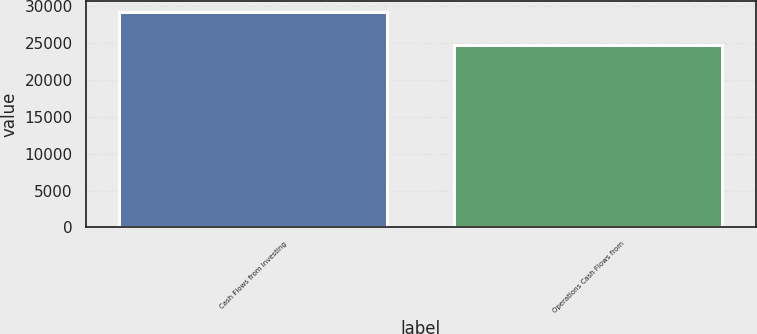<chart> <loc_0><loc_0><loc_500><loc_500><bar_chart><fcel>Cash Flows from Investing<fcel>Operations Cash Flows from<nl><fcel>29178<fcel>24751<nl></chart> 